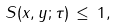<formula> <loc_0><loc_0><loc_500><loc_500>S ( x , y ; \tau ) \, \leq \, 1 ,</formula> 